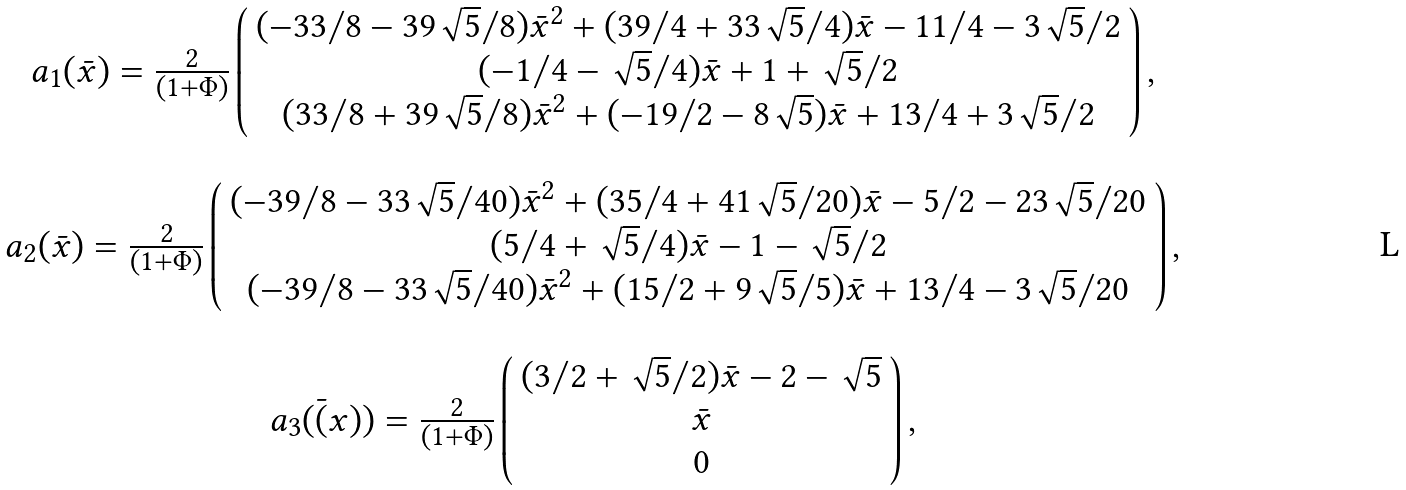<formula> <loc_0><loc_0><loc_500><loc_500>\begin{array} { c } { a } _ { 1 } ( \bar { x } ) = \frac { 2 } { ( 1 + \Phi ) } \left ( { \begin{array} { c } ( - 3 3 / 8 - 3 9 \sqrt { 5 } / 8 ) \bar { x } ^ { 2 } + ( 3 9 / 4 + 3 3 \sqrt { 5 } / 4 ) \bar { x } - 1 1 / 4 - 3 \sqrt { 5 } / 2 \\ ( - 1 / 4 - \sqrt { 5 } / 4 ) \bar { x } + 1 + \sqrt { 5 } / 2 \\ ( 3 3 / 8 + 3 9 \sqrt { 5 } / 8 ) \bar { x } ^ { 2 } + ( - 1 9 / 2 - 8 \sqrt { 5 } ) \bar { x } + 1 3 / 4 + 3 \sqrt { 5 } / 2 \end{array} } \right ) , \\ \\ { a } _ { 2 } ( \bar { x } ) = \frac { 2 } { ( 1 + \Phi ) } \left ( { \begin{array} { c } ( - 3 9 / 8 - 3 3 \sqrt { 5 } / 4 0 ) \bar { x } ^ { 2 } + ( 3 5 / 4 + 4 1 \sqrt { 5 } / 2 0 ) \bar { x } - 5 / 2 - 2 3 \sqrt { 5 } / 2 0 \\ ( 5 / 4 + \sqrt { 5 } / 4 ) \bar { x } - 1 - \sqrt { 5 } / 2 \\ ( - 3 9 / 8 - 3 3 \sqrt { 5 } / 4 0 ) \bar { x } ^ { 2 } + ( 1 5 / 2 + 9 \sqrt { 5 } / 5 ) \bar { x } + 1 3 / 4 - 3 \sqrt { 5 } / 2 0 \end{array} } \right ) , \\ \\ { a } _ { 3 } ( \bar { ( } x ) ) = \frac { 2 } { ( 1 + \Phi ) } \left ( { \begin{array} { c } ( 3 / 2 + \sqrt { 5 } / 2 ) \bar { x } - 2 - \sqrt { 5 } \\ \bar { x } \\ 0 \end{array} } \right ) , \end{array}</formula> 